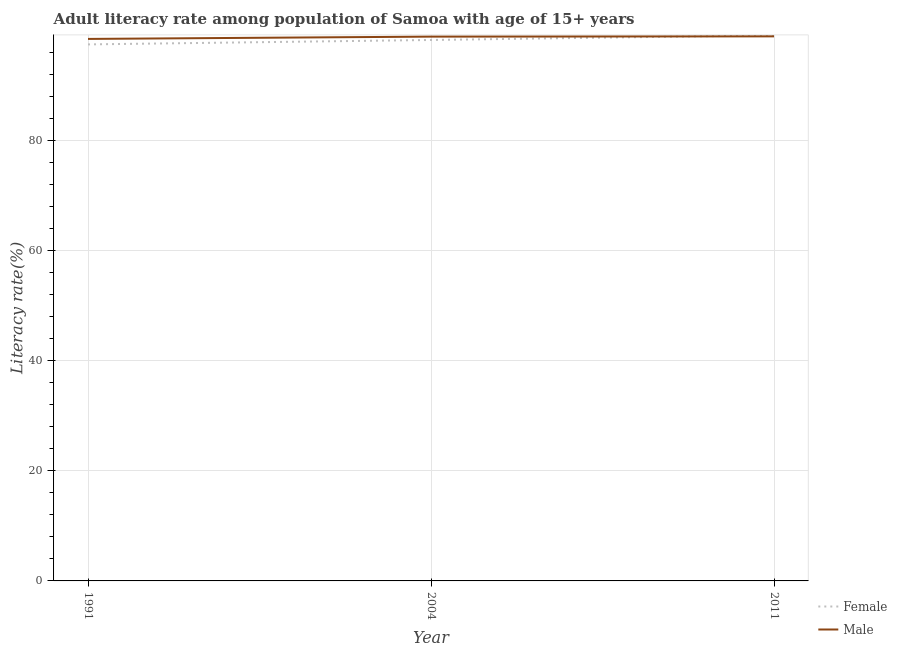Does the line corresponding to female adult literacy rate intersect with the line corresponding to male adult literacy rate?
Ensure brevity in your answer.  Yes. What is the female adult literacy rate in 2004?
Provide a succinct answer. 98.23. Across all years, what is the maximum male adult literacy rate?
Keep it short and to the point. 98.88. Across all years, what is the minimum male adult literacy rate?
Your answer should be compact. 98.42. In which year was the female adult literacy rate maximum?
Your answer should be very brief. 2011. What is the total female adult literacy rate in the graph?
Your answer should be compact. 294.72. What is the difference between the female adult literacy rate in 1991 and that in 2011?
Provide a succinct answer. -1.65. What is the difference between the female adult literacy rate in 2011 and the male adult literacy rate in 2004?
Provide a short and direct response. 0.23. What is the average male adult literacy rate per year?
Your answer should be compact. 98.71. In the year 1991, what is the difference between the male adult literacy rate and female adult literacy rate?
Provide a succinct answer. 0.99. In how many years, is the female adult literacy rate greater than 56 %?
Ensure brevity in your answer.  3. What is the ratio of the male adult literacy rate in 1991 to that in 2004?
Provide a succinct answer. 1. What is the difference between the highest and the second highest male adult literacy rate?
Offer a terse response. 0.05. What is the difference between the highest and the lowest female adult literacy rate?
Ensure brevity in your answer.  1.65. Is the sum of the male adult literacy rate in 2004 and 2011 greater than the maximum female adult literacy rate across all years?
Ensure brevity in your answer.  Yes. Does the female adult literacy rate monotonically increase over the years?
Keep it short and to the point. Yes. Is the male adult literacy rate strictly greater than the female adult literacy rate over the years?
Ensure brevity in your answer.  No. How many lines are there?
Provide a short and direct response. 2. What is the difference between two consecutive major ticks on the Y-axis?
Your response must be concise. 20. Are the values on the major ticks of Y-axis written in scientific E-notation?
Keep it short and to the point. No. Does the graph contain grids?
Your answer should be very brief. Yes. What is the title of the graph?
Provide a succinct answer. Adult literacy rate among population of Samoa with age of 15+ years. What is the label or title of the Y-axis?
Provide a short and direct response. Literacy rate(%). What is the Literacy rate(%) of Female in 1991?
Offer a very short reply. 97.42. What is the Literacy rate(%) of Male in 1991?
Provide a short and direct response. 98.42. What is the Literacy rate(%) in Female in 2004?
Provide a succinct answer. 98.23. What is the Literacy rate(%) in Male in 2004?
Your response must be concise. 98.84. What is the Literacy rate(%) of Female in 2011?
Offer a terse response. 99.07. What is the Literacy rate(%) of Male in 2011?
Ensure brevity in your answer.  98.88. Across all years, what is the maximum Literacy rate(%) of Female?
Your answer should be compact. 99.07. Across all years, what is the maximum Literacy rate(%) of Male?
Offer a terse response. 98.88. Across all years, what is the minimum Literacy rate(%) of Female?
Give a very brief answer. 97.42. Across all years, what is the minimum Literacy rate(%) in Male?
Give a very brief answer. 98.42. What is the total Literacy rate(%) in Female in the graph?
Your answer should be very brief. 294.72. What is the total Literacy rate(%) in Male in the graph?
Provide a short and direct response. 296.13. What is the difference between the Literacy rate(%) of Female in 1991 and that in 2004?
Provide a succinct answer. -0.8. What is the difference between the Literacy rate(%) of Male in 1991 and that in 2004?
Give a very brief answer. -0.42. What is the difference between the Literacy rate(%) of Female in 1991 and that in 2011?
Offer a terse response. -1.65. What is the difference between the Literacy rate(%) in Male in 1991 and that in 2011?
Your response must be concise. -0.47. What is the difference between the Literacy rate(%) in Female in 2004 and that in 2011?
Offer a terse response. -0.84. What is the difference between the Literacy rate(%) in Male in 2004 and that in 2011?
Offer a terse response. -0.05. What is the difference between the Literacy rate(%) in Female in 1991 and the Literacy rate(%) in Male in 2004?
Provide a short and direct response. -1.41. What is the difference between the Literacy rate(%) in Female in 1991 and the Literacy rate(%) in Male in 2011?
Offer a terse response. -1.46. What is the difference between the Literacy rate(%) of Female in 2004 and the Literacy rate(%) of Male in 2011?
Provide a short and direct response. -0.66. What is the average Literacy rate(%) of Female per year?
Your answer should be very brief. 98.24. What is the average Literacy rate(%) in Male per year?
Provide a short and direct response. 98.71. In the year 1991, what is the difference between the Literacy rate(%) in Female and Literacy rate(%) in Male?
Offer a very short reply. -0.99. In the year 2004, what is the difference between the Literacy rate(%) of Female and Literacy rate(%) of Male?
Keep it short and to the point. -0.61. In the year 2011, what is the difference between the Literacy rate(%) of Female and Literacy rate(%) of Male?
Give a very brief answer. 0.19. What is the ratio of the Literacy rate(%) of Female in 1991 to that in 2004?
Your answer should be very brief. 0.99. What is the ratio of the Literacy rate(%) in Female in 1991 to that in 2011?
Provide a succinct answer. 0.98. What is the ratio of the Literacy rate(%) in Female in 2004 to that in 2011?
Your answer should be compact. 0.99. What is the difference between the highest and the second highest Literacy rate(%) in Female?
Provide a succinct answer. 0.84. What is the difference between the highest and the second highest Literacy rate(%) of Male?
Give a very brief answer. 0.05. What is the difference between the highest and the lowest Literacy rate(%) in Female?
Ensure brevity in your answer.  1.65. What is the difference between the highest and the lowest Literacy rate(%) of Male?
Make the answer very short. 0.47. 